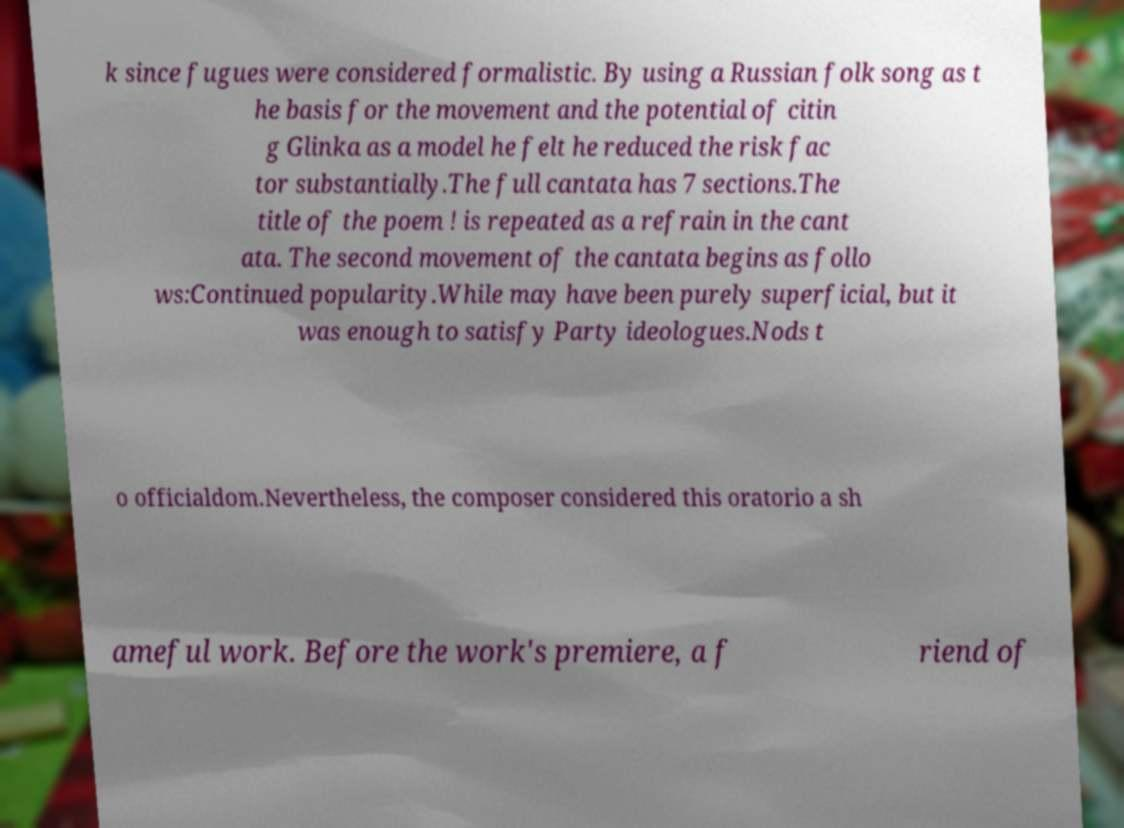Please read and relay the text visible in this image. What does it say? k since fugues were considered formalistic. By using a Russian folk song as t he basis for the movement and the potential of citin g Glinka as a model he felt he reduced the risk fac tor substantially.The full cantata has 7 sections.The title of the poem ! is repeated as a refrain in the cant ata. The second movement of the cantata begins as follo ws:Continued popularity.While may have been purely superficial, but it was enough to satisfy Party ideologues.Nods t o officialdom.Nevertheless, the composer considered this oratorio a sh ameful work. Before the work's premiere, a f riend of 